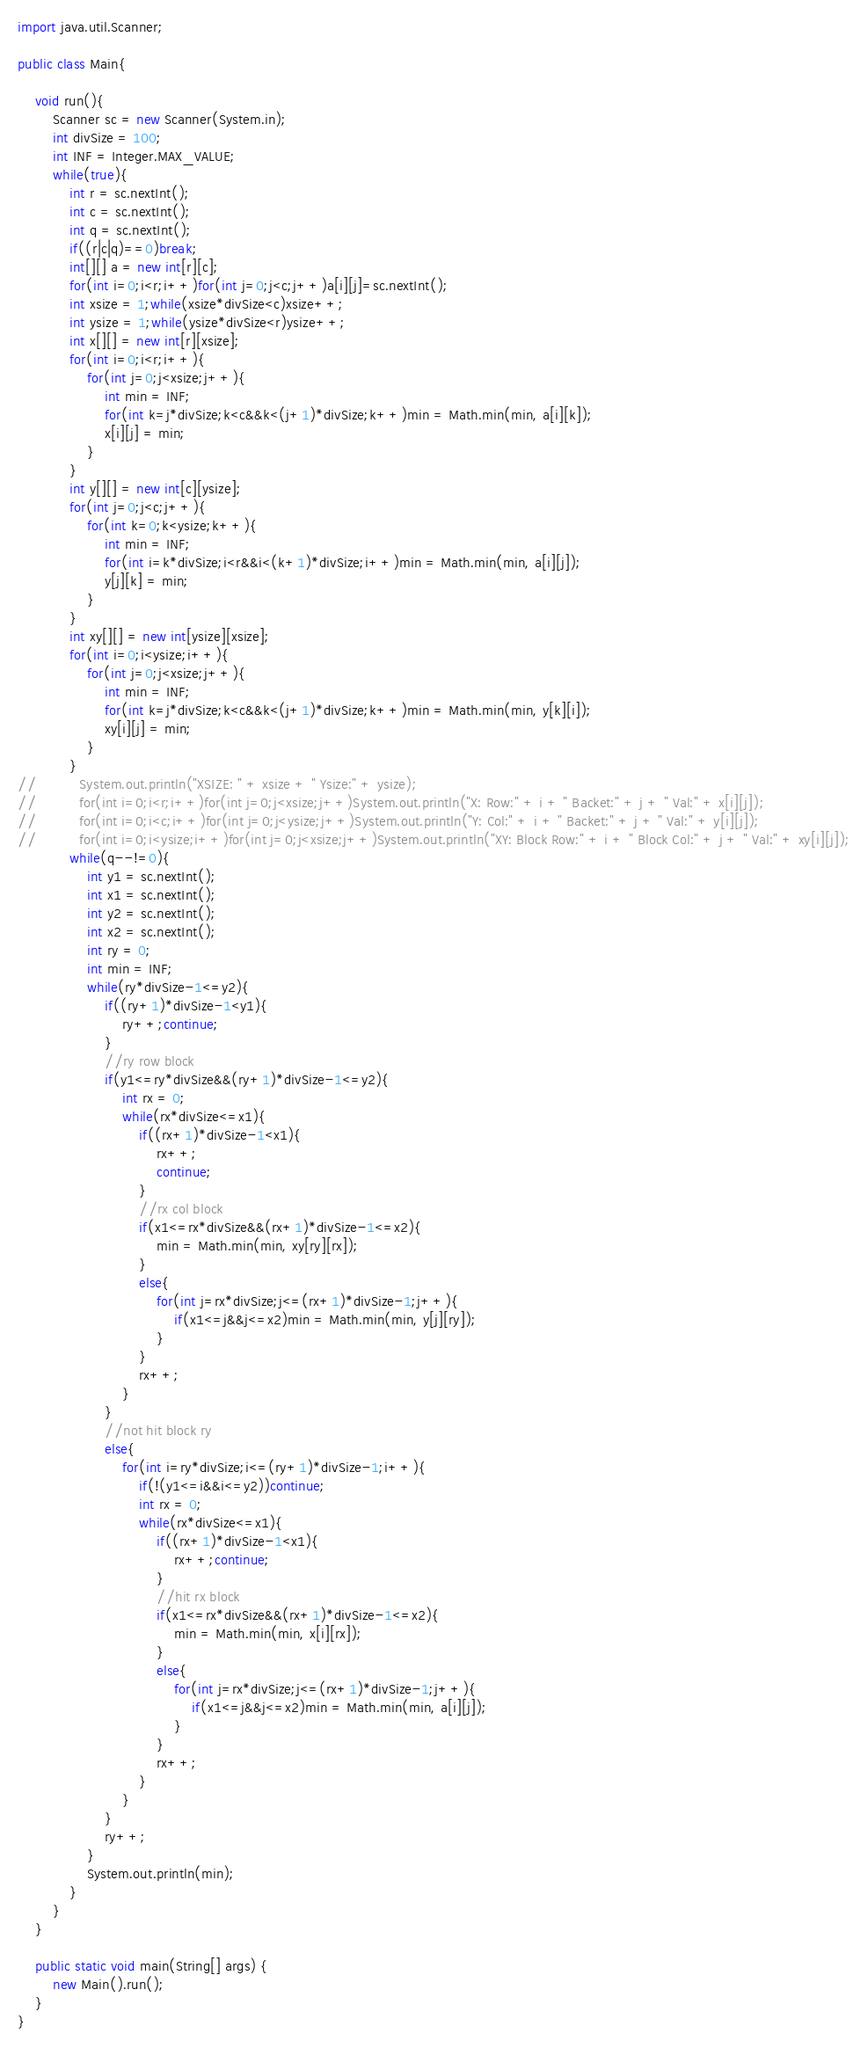<code> <loc_0><loc_0><loc_500><loc_500><_Java_>import java.util.Scanner;

public class Main{

	void run(){
		Scanner sc = new Scanner(System.in);
		int divSize = 100;
		int INF = Integer.MAX_VALUE;
		while(true){
			int r = sc.nextInt();
			int c = sc.nextInt();
			int q = sc.nextInt();
			if((r|c|q)==0)break;
			int[][] a = new int[r][c];
			for(int i=0;i<r;i++)for(int j=0;j<c;j++)a[i][j]=sc.nextInt();
			int xsize = 1;while(xsize*divSize<c)xsize++;
			int ysize = 1;while(ysize*divSize<r)ysize++;
			int x[][] = new int[r][xsize];
			for(int i=0;i<r;i++){
				for(int j=0;j<xsize;j++){
					int min = INF;
					for(int k=j*divSize;k<c&&k<(j+1)*divSize;k++)min = Math.min(min, a[i][k]);
					x[i][j] = min;
				}
			}
			int y[][] = new int[c][ysize];
			for(int j=0;j<c;j++){
				for(int k=0;k<ysize;k++){
					int min = INF;
					for(int i=k*divSize;i<r&&i<(k+1)*divSize;i++)min = Math.min(min, a[i][j]);
					y[j][k] = min;
				}
			}
			int xy[][] = new int[ysize][xsize];
			for(int i=0;i<ysize;i++){
				for(int j=0;j<xsize;j++){
					int min = INF;
					for(int k=j*divSize;k<c&&k<(j+1)*divSize;k++)min = Math.min(min, y[k][i]);
					xy[i][j] = min;
				}
			}
//			System.out.println("XSIZE: " + xsize + " Ysize:" + ysize);
//			for(int i=0;i<r;i++)for(int j=0;j<xsize;j++)System.out.println("X: Row:" + i + " Backet:" + j + " Val:" + x[i][j]);
//			for(int i=0;i<c;i++)for(int j=0;j<ysize;j++)System.out.println("Y: Col:" + i + " Backet:" + j + " Val:" + y[i][j]);
//			for(int i=0;i<ysize;i++)for(int j=0;j<xsize;j++)System.out.println("XY: Block Row:" + i + " Block Col:" + j + " Val:" + xy[i][j]);
			while(q--!=0){
				int y1 = sc.nextInt();
				int x1 = sc.nextInt();
				int y2 = sc.nextInt();
				int x2 = sc.nextInt();
				int ry = 0;
				int min = INF;
				while(ry*divSize-1<=y2){
					if((ry+1)*divSize-1<y1){
						ry++;continue;
					}
					//ry row block
					if(y1<=ry*divSize&&(ry+1)*divSize-1<=y2){
						int rx = 0;
						while(rx*divSize<=x1){
							if((rx+1)*divSize-1<x1){
								rx++;
								continue;
							}
							//rx col block
							if(x1<=rx*divSize&&(rx+1)*divSize-1<=x2){
								min = Math.min(min, xy[ry][rx]);
							}
							else{
								for(int j=rx*divSize;j<=(rx+1)*divSize-1;j++){
									if(x1<=j&&j<=x2)min = Math.min(min, y[j][ry]);
								}
							}
							rx++;
						}
					}
					//not hit block ry
					else{
						for(int i=ry*divSize;i<=(ry+1)*divSize-1;i++){
							if(!(y1<=i&&i<=y2))continue;
							int rx = 0;
							while(rx*divSize<=x1){
								if((rx+1)*divSize-1<x1){
									rx++;continue;
								}
								//hit rx block
								if(x1<=rx*divSize&&(rx+1)*divSize-1<=x2){
									min = Math.min(min, x[i][rx]);
								}
								else{
									for(int j=rx*divSize;j<=(rx+1)*divSize-1;j++){
										if(x1<=j&&j<=x2)min = Math.min(min, a[i][j]);
									}
								}
								rx++;
							}
						}
					}
					ry++;
				}
				System.out.println(min);
			}
		}
	}

	public static void main(String[] args) {
		new Main().run();
	}
}</code> 